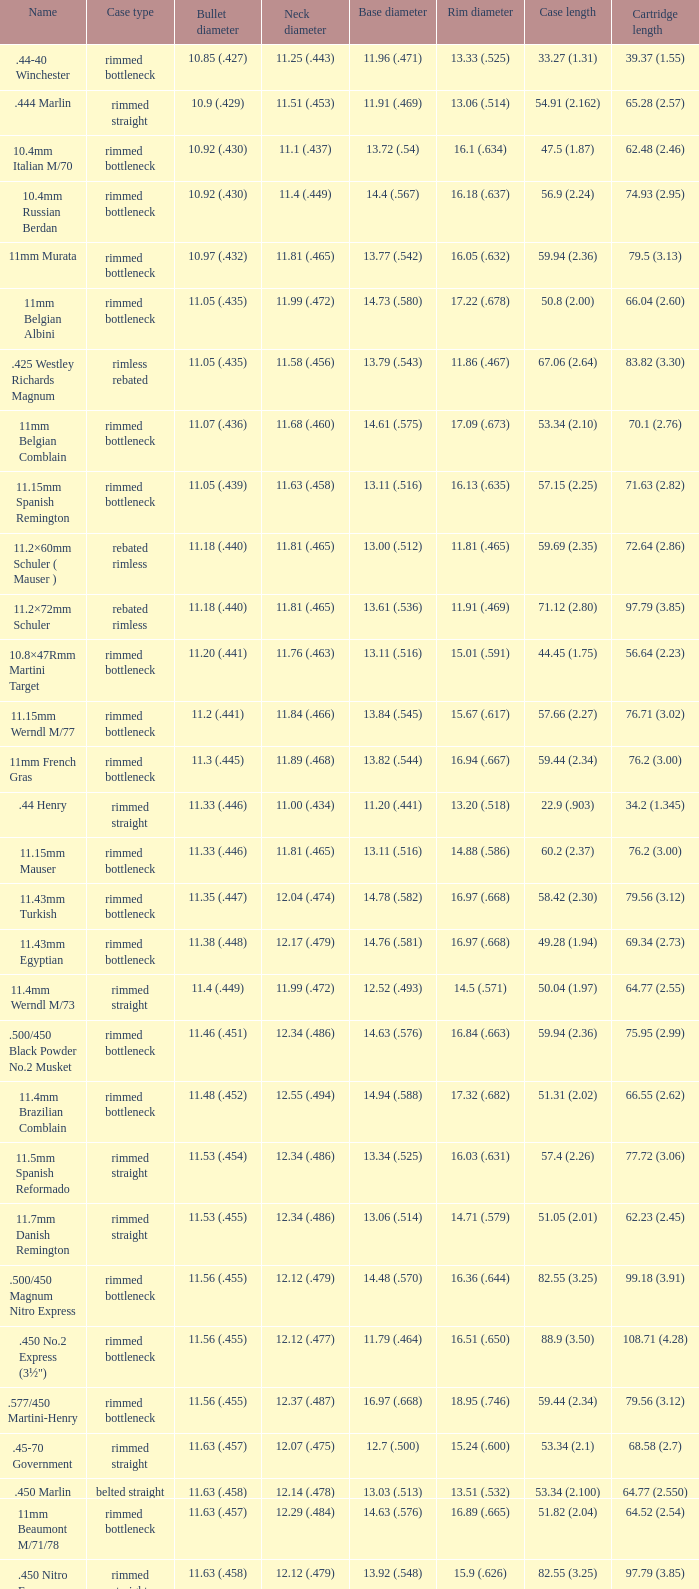Which Rim diameter has a Neck diameter of 11.84 (.466)? 15.67 (.617). 